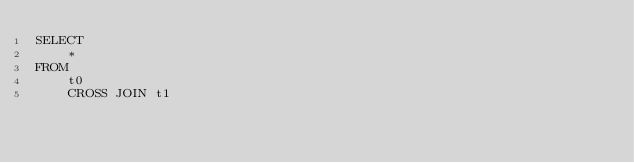<code> <loc_0><loc_0><loc_500><loc_500><_SQL_>SELECT
    *
FROM
    t0
    CROSS JOIN t1
</code> 